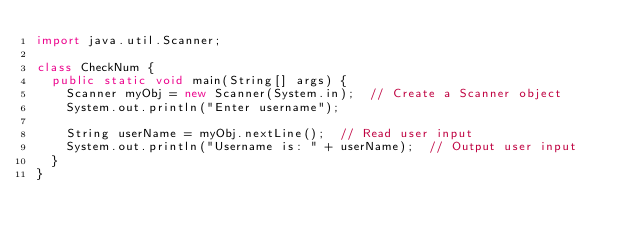Convert code to text. <code><loc_0><loc_0><loc_500><loc_500><_Java_>import java.util.Scanner;  

class CheckNum {
  public static void main(String[] args) {
    Scanner myObj = new Scanner(System.in);  // Create a Scanner object
    System.out.println("Enter username");

    String userName = myObj.nextLine();  // Read user input
    System.out.println("Username is: " + userName);  // Output user input
  }
}</code> 